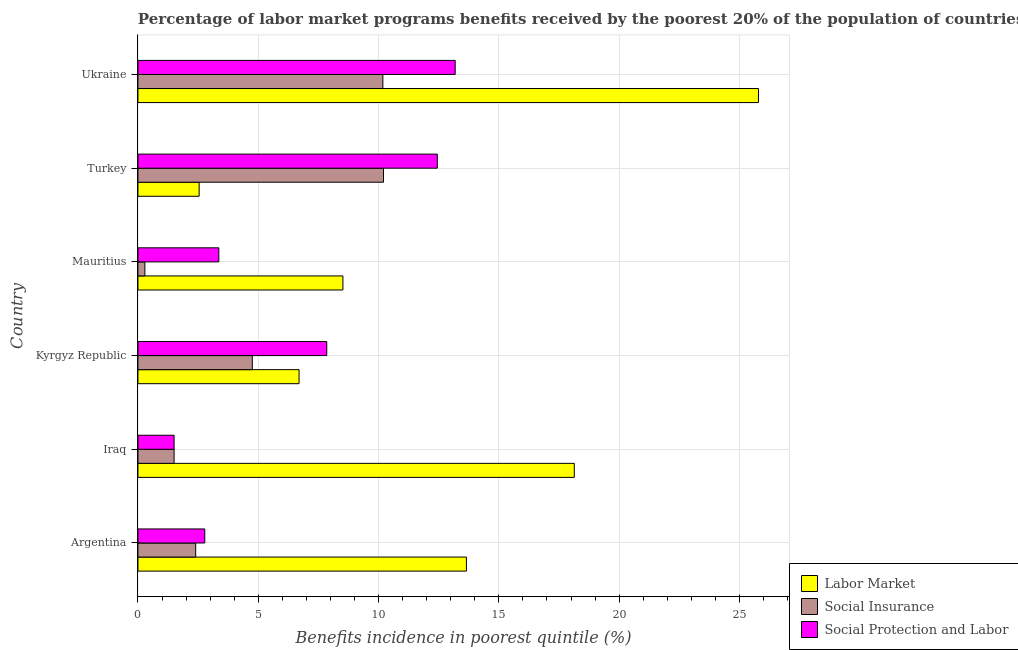How many different coloured bars are there?
Ensure brevity in your answer.  3. Are the number of bars per tick equal to the number of legend labels?
Your answer should be very brief. Yes. Are the number of bars on each tick of the Y-axis equal?
Offer a terse response. Yes. How many bars are there on the 4th tick from the top?
Your answer should be compact. 3. What is the label of the 1st group of bars from the top?
Your answer should be very brief. Ukraine. In how many cases, is the number of bars for a given country not equal to the number of legend labels?
Ensure brevity in your answer.  0. What is the percentage of benefits received due to social protection programs in Argentina?
Make the answer very short. 2.78. Across all countries, what is the maximum percentage of benefits received due to social insurance programs?
Your answer should be very brief. 10.21. Across all countries, what is the minimum percentage of benefits received due to social protection programs?
Keep it short and to the point. 1.5. In which country was the percentage of benefits received due to labor market programs minimum?
Your answer should be very brief. Turkey. What is the total percentage of benefits received due to social protection programs in the graph?
Give a very brief answer. 41.11. What is the difference between the percentage of benefits received due to social protection programs in Mauritius and that in Ukraine?
Offer a terse response. -9.82. What is the difference between the percentage of benefits received due to labor market programs in Turkey and the percentage of benefits received due to social insurance programs in Iraq?
Offer a very short reply. 1.04. What is the average percentage of benefits received due to social protection programs per country?
Keep it short and to the point. 6.85. What is the difference between the percentage of benefits received due to labor market programs and percentage of benefits received due to social protection programs in Kyrgyz Republic?
Ensure brevity in your answer.  -1.15. What is the ratio of the percentage of benefits received due to social insurance programs in Iraq to that in Ukraine?
Your answer should be very brief. 0.15. Is the percentage of benefits received due to social insurance programs in Iraq less than that in Turkey?
Give a very brief answer. Yes. What is the difference between the highest and the second highest percentage of benefits received due to social insurance programs?
Offer a terse response. 0.03. What is the difference between the highest and the lowest percentage of benefits received due to social protection programs?
Your answer should be very brief. 11.68. What does the 1st bar from the top in Mauritius represents?
Your response must be concise. Social Protection and Labor. What does the 2nd bar from the bottom in Argentina represents?
Make the answer very short. Social Insurance. How many bars are there?
Ensure brevity in your answer.  18. Are all the bars in the graph horizontal?
Provide a short and direct response. Yes. How many countries are there in the graph?
Your response must be concise. 6. What is the difference between two consecutive major ticks on the X-axis?
Ensure brevity in your answer.  5. Are the values on the major ticks of X-axis written in scientific E-notation?
Your answer should be compact. No. Does the graph contain any zero values?
Give a very brief answer. No. Does the graph contain grids?
Your response must be concise. Yes. Where does the legend appear in the graph?
Your response must be concise. Bottom right. How many legend labels are there?
Provide a succinct answer. 3. How are the legend labels stacked?
Provide a short and direct response. Vertical. What is the title of the graph?
Make the answer very short. Percentage of labor market programs benefits received by the poorest 20% of the population of countries. What is the label or title of the X-axis?
Offer a terse response. Benefits incidence in poorest quintile (%). What is the Benefits incidence in poorest quintile (%) of Labor Market in Argentina?
Your answer should be compact. 13.65. What is the Benefits incidence in poorest quintile (%) of Social Insurance in Argentina?
Give a very brief answer. 2.4. What is the Benefits incidence in poorest quintile (%) of Social Protection and Labor in Argentina?
Provide a succinct answer. 2.78. What is the Benefits incidence in poorest quintile (%) of Labor Market in Iraq?
Your answer should be compact. 18.14. What is the Benefits incidence in poorest quintile (%) in Social Insurance in Iraq?
Provide a short and direct response. 1.5. What is the Benefits incidence in poorest quintile (%) in Social Protection and Labor in Iraq?
Your answer should be compact. 1.5. What is the Benefits incidence in poorest quintile (%) of Labor Market in Kyrgyz Republic?
Make the answer very short. 6.7. What is the Benefits incidence in poorest quintile (%) of Social Insurance in Kyrgyz Republic?
Your answer should be compact. 4.75. What is the Benefits incidence in poorest quintile (%) of Social Protection and Labor in Kyrgyz Republic?
Provide a short and direct response. 7.85. What is the Benefits incidence in poorest quintile (%) of Labor Market in Mauritius?
Your answer should be very brief. 8.52. What is the Benefits incidence in poorest quintile (%) of Social Insurance in Mauritius?
Offer a very short reply. 0.29. What is the Benefits incidence in poorest quintile (%) in Social Protection and Labor in Mauritius?
Provide a succinct answer. 3.36. What is the Benefits incidence in poorest quintile (%) in Labor Market in Turkey?
Keep it short and to the point. 2.54. What is the Benefits incidence in poorest quintile (%) of Social Insurance in Turkey?
Give a very brief answer. 10.21. What is the Benefits incidence in poorest quintile (%) in Social Protection and Labor in Turkey?
Give a very brief answer. 12.44. What is the Benefits incidence in poorest quintile (%) of Labor Market in Ukraine?
Your answer should be compact. 25.79. What is the Benefits incidence in poorest quintile (%) of Social Insurance in Ukraine?
Make the answer very short. 10.18. What is the Benefits incidence in poorest quintile (%) in Social Protection and Labor in Ukraine?
Keep it short and to the point. 13.19. Across all countries, what is the maximum Benefits incidence in poorest quintile (%) of Labor Market?
Your answer should be very brief. 25.79. Across all countries, what is the maximum Benefits incidence in poorest quintile (%) in Social Insurance?
Ensure brevity in your answer.  10.21. Across all countries, what is the maximum Benefits incidence in poorest quintile (%) in Social Protection and Labor?
Provide a short and direct response. 13.19. Across all countries, what is the minimum Benefits incidence in poorest quintile (%) of Labor Market?
Your response must be concise. 2.54. Across all countries, what is the minimum Benefits incidence in poorest quintile (%) of Social Insurance?
Ensure brevity in your answer.  0.29. Across all countries, what is the minimum Benefits incidence in poorest quintile (%) of Social Protection and Labor?
Ensure brevity in your answer.  1.5. What is the total Benefits incidence in poorest quintile (%) in Labor Market in the graph?
Make the answer very short. 75.33. What is the total Benefits incidence in poorest quintile (%) of Social Insurance in the graph?
Provide a short and direct response. 29.33. What is the total Benefits incidence in poorest quintile (%) of Social Protection and Labor in the graph?
Give a very brief answer. 41.11. What is the difference between the Benefits incidence in poorest quintile (%) in Labor Market in Argentina and that in Iraq?
Your answer should be very brief. -4.48. What is the difference between the Benefits incidence in poorest quintile (%) in Social Insurance in Argentina and that in Iraq?
Your response must be concise. 0.9. What is the difference between the Benefits incidence in poorest quintile (%) in Social Protection and Labor in Argentina and that in Iraq?
Your response must be concise. 1.27. What is the difference between the Benefits incidence in poorest quintile (%) of Labor Market in Argentina and that in Kyrgyz Republic?
Provide a succinct answer. 6.96. What is the difference between the Benefits incidence in poorest quintile (%) in Social Insurance in Argentina and that in Kyrgyz Republic?
Offer a very short reply. -2.35. What is the difference between the Benefits incidence in poorest quintile (%) in Social Protection and Labor in Argentina and that in Kyrgyz Republic?
Your answer should be compact. -5.07. What is the difference between the Benefits incidence in poorest quintile (%) of Labor Market in Argentina and that in Mauritius?
Keep it short and to the point. 5.13. What is the difference between the Benefits incidence in poorest quintile (%) of Social Insurance in Argentina and that in Mauritius?
Provide a succinct answer. 2.11. What is the difference between the Benefits incidence in poorest quintile (%) in Social Protection and Labor in Argentina and that in Mauritius?
Provide a short and direct response. -0.58. What is the difference between the Benefits incidence in poorest quintile (%) of Labor Market in Argentina and that in Turkey?
Ensure brevity in your answer.  11.11. What is the difference between the Benefits incidence in poorest quintile (%) of Social Insurance in Argentina and that in Turkey?
Provide a succinct answer. -7.81. What is the difference between the Benefits incidence in poorest quintile (%) of Social Protection and Labor in Argentina and that in Turkey?
Give a very brief answer. -9.66. What is the difference between the Benefits incidence in poorest quintile (%) of Labor Market in Argentina and that in Ukraine?
Provide a succinct answer. -12.14. What is the difference between the Benefits incidence in poorest quintile (%) in Social Insurance in Argentina and that in Ukraine?
Offer a very short reply. -7.78. What is the difference between the Benefits incidence in poorest quintile (%) of Social Protection and Labor in Argentina and that in Ukraine?
Your answer should be very brief. -10.41. What is the difference between the Benefits incidence in poorest quintile (%) of Labor Market in Iraq and that in Kyrgyz Republic?
Offer a very short reply. 11.44. What is the difference between the Benefits incidence in poorest quintile (%) of Social Insurance in Iraq and that in Kyrgyz Republic?
Your response must be concise. -3.25. What is the difference between the Benefits incidence in poorest quintile (%) in Social Protection and Labor in Iraq and that in Kyrgyz Republic?
Make the answer very short. -6.34. What is the difference between the Benefits incidence in poorest quintile (%) in Labor Market in Iraq and that in Mauritius?
Your response must be concise. 9.62. What is the difference between the Benefits incidence in poorest quintile (%) of Social Insurance in Iraq and that in Mauritius?
Make the answer very short. 1.22. What is the difference between the Benefits incidence in poorest quintile (%) of Social Protection and Labor in Iraq and that in Mauritius?
Ensure brevity in your answer.  -1.86. What is the difference between the Benefits incidence in poorest quintile (%) of Labor Market in Iraq and that in Turkey?
Make the answer very short. 15.59. What is the difference between the Benefits incidence in poorest quintile (%) of Social Insurance in Iraq and that in Turkey?
Your answer should be very brief. -8.7. What is the difference between the Benefits incidence in poorest quintile (%) of Social Protection and Labor in Iraq and that in Turkey?
Make the answer very short. -10.94. What is the difference between the Benefits incidence in poorest quintile (%) in Labor Market in Iraq and that in Ukraine?
Provide a short and direct response. -7.65. What is the difference between the Benefits incidence in poorest quintile (%) in Social Insurance in Iraq and that in Ukraine?
Ensure brevity in your answer.  -8.68. What is the difference between the Benefits incidence in poorest quintile (%) of Social Protection and Labor in Iraq and that in Ukraine?
Ensure brevity in your answer.  -11.68. What is the difference between the Benefits incidence in poorest quintile (%) in Labor Market in Kyrgyz Republic and that in Mauritius?
Offer a terse response. -1.82. What is the difference between the Benefits incidence in poorest quintile (%) in Social Insurance in Kyrgyz Republic and that in Mauritius?
Offer a very short reply. 4.47. What is the difference between the Benefits incidence in poorest quintile (%) of Social Protection and Labor in Kyrgyz Republic and that in Mauritius?
Provide a succinct answer. 4.49. What is the difference between the Benefits incidence in poorest quintile (%) of Labor Market in Kyrgyz Republic and that in Turkey?
Give a very brief answer. 4.15. What is the difference between the Benefits incidence in poorest quintile (%) in Social Insurance in Kyrgyz Republic and that in Turkey?
Give a very brief answer. -5.45. What is the difference between the Benefits incidence in poorest quintile (%) of Social Protection and Labor in Kyrgyz Republic and that in Turkey?
Your response must be concise. -4.59. What is the difference between the Benefits incidence in poorest quintile (%) in Labor Market in Kyrgyz Republic and that in Ukraine?
Your answer should be very brief. -19.09. What is the difference between the Benefits incidence in poorest quintile (%) in Social Insurance in Kyrgyz Republic and that in Ukraine?
Offer a very short reply. -5.43. What is the difference between the Benefits incidence in poorest quintile (%) of Social Protection and Labor in Kyrgyz Republic and that in Ukraine?
Offer a terse response. -5.34. What is the difference between the Benefits incidence in poorest quintile (%) in Labor Market in Mauritius and that in Turkey?
Offer a terse response. 5.97. What is the difference between the Benefits incidence in poorest quintile (%) in Social Insurance in Mauritius and that in Turkey?
Make the answer very short. -9.92. What is the difference between the Benefits incidence in poorest quintile (%) of Social Protection and Labor in Mauritius and that in Turkey?
Make the answer very short. -9.08. What is the difference between the Benefits incidence in poorest quintile (%) in Labor Market in Mauritius and that in Ukraine?
Provide a succinct answer. -17.27. What is the difference between the Benefits incidence in poorest quintile (%) in Social Insurance in Mauritius and that in Ukraine?
Give a very brief answer. -9.89. What is the difference between the Benefits incidence in poorest quintile (%) in Social Protection and Labor in Mauritius and that in Ukraine?
Give a very brief answer. -9.82. What is the difference between the Benefits incidence in poorest quintile (%) in Labor Market in Turkey and that in Ukraine?
Provide a succinct answer. -23.25. What is the difference between the Benefits incidence in poorest quintile (%) in Social Insurance in Turkey and that in Ukraine?
Provide a short and direct response. 0.03. What is the difference between the Benefits incidence in poorest quintile (%) of Social Protection and Labor in Turkey and that in Ukraine?
Your response must be concise. -0.74. What is the difference between the Benefits incidence in poorest quintile (%) of Labor Market in Argentina and the Benefits incidence in poorest quintile (%) of Social Insurance in Iraq?
Offer a very short reply. 12.15. What is the difference between the Benefits incidence in poorest quintile (%) in Labor Market in Argentina and the Benefits incidence in poorest quintile (%) in Social Protection and Labor in Iraq?
Make the answer very short. 12.15. What is the difference between the Benefits incidence in poorest quintile (%) in Social Insurance in Argentina and the Benefits incidence in poorest quintile (%) in Social Protection and Labor in Iraq?
Your answer should be compact. 0.9. What is the difference between the Benefits incidence in poorest quintile (%) in Labor Market in Argentina and the Benefits incidence in poorest quintile (%) in Social Insurance in Kyrgyz Republic?
Offer a very short reply. 8.9. What is the difference between the Benefits incidence in poorest quintile (%) in Labor Market in Argentina and the Benefits incidence in poorest quintile (%) in Social Protection and Labor in Kyrgyz Republic?
Your answer should be very brief. 5.8. What is the difference between the Benefits incidence in poorest quintile (%) of Social Insurance in Argentina and the Benefits incidence in poorest quintile (%) of Social Protection and Labor in Kyrgyz Republic?
Your response must be concise. -5.45. What is the difference between the Benefits incidence in poorest quintile (%) in Labor Market in Argentina and the Benefits incidence in poorest quintile (%) in Social Insurance in Mauritius?
Ensure brevity in your answer.  13.36. What is the difference between the Benefits incidence in poorest quintile (%) in Labor Market in Argentina and the Benefits incidence in poorest quintile (%) in Social Protection and Labor in Mauritius?
Make the answer very short. 10.29. What is the difference between the Benefits incidence in poorest quintile (%) in Social Insurance in Argentina and the Benefits incidence in poorest quintile (%) in Social Protection and Labor in Mauritius?
Keep it short and to the point. -0.96. What is the difference between the Benefits incidence in poorest quintile (%) in Labor Market in Argentina and the Benefits incidence in poorest quintile (%) in Social Insurance in Turkey?
Your response must be concise. 3.45. What is the difference between the Benefits incidence in poorest quintile (%) of Labor Market in Argentina and the Benefits incidence in poorest quintile (%) of Social Protection and Labor in Turkey?
Your response must be concise. 1.21. What is the difference between the Benefits incidence in poorest quintile (%) in Social Insurance in Argentina and the Benefits incidence in poorest quintile (%) in Social Protection and Labor in Turkey?
Provide a succinct answer. -10.04. What is the difference between the Benefits incidence in poorest quintile (%) in Labor Market in Argentina and the Benefits incidence in poorest quintile (%) in Social Insurance in Ukraine?
Provide a short and direct response. 3.47. What is the difference between the Benefits incidence in poorest quintile (%) of Labor Market in Argentina and the Benefits incidence in poorest quintile (%) of Social Protection and Labor in Ukraine?
Offer a terse response. 0.47. What is the difference between the Benefits incidence in poorest quintile (%) of Social Insurance in Argentina and the Benefits incidence in poorest quintile (%) of Social Protection and Labor in Ukraine?
Keep it short and to the point. -10.79. What is the difference between the Benefits incidence in poorest quintile (%) of Labor Market in Iraq and the Benefits incidence in poorest quintile (%) of Social Insurance in Kyrgyz Republic?
Offer a very short reply. 13.38. What is the difference between the Benefits incidence in poorest quintile (%) in Labor Market in Iraq and the Benefits incidence in poorest quintile (%) in Social Protection and Labor in Kyrgyz Republic?
Make the answer very short. 10.29. What is the difference between the Benefits incidence in poorest quintile (%) in Social Insurance in Iraq and the Benefits incidence in poorest quintile (%) in Social Protection and Labor in Kyrgyz Republic?
Make the answer very short. -6.34. What is the difference between the Benefits incidence in poorest quintile (%) in Labor Market in Iraq and the Benefits incidence in poorest quintile (%) in Social Insurance in Mauritius?
Your response must be concise. 17.85. What is the difference between the Benefits incidence in poorest quintile (%) in Labor Market in Iraq and the Benefits incidence in poorest quintile (%) in Social Protection and Labor in Mauritius?
Your answer should be very brief. 14.78. What is the difference between the Benefits incidence in poorest quintile (%) of Social Insurance in Iraq and the Benefits incidence in poorest quintile (%) of Social Protection and Labor in Mauritius?
Ensure brevity in your answer.  -1.86. What is the difference between the Benefits incidence in poorest quintile (%) in Labor Market in Iraq and the Benefits incidence in poorest quintile (%) in Social Insurance in Turkey?
Give a very brief answer. 7.93. What is the difference between the Benefits incidence in poorest quintile (%) in Labor Market in Iraq and the Benefits incidence in poorest quintile (%) in Social Protection and Labor in Turkey?
Your answer should be compact. 5.69. What is the difference between the Benefits incidence in poorest quintile (%) in Social Insurance in Iraq and the Benefits incidence in poorest quintile (%) in Social Protection and Labor in Turkey?
Provide a succinct answer. -10.94. What is the difference between the Benefits incidence in poorest quintile (%) in Labor Market in Iraq and the Benefits incidence in poorest quintile (%) in Social Insurance in Ukraine?
Your answer should be very brief. 7.96. What is the difference between the Benefits incidence in poorest quintile (%) in Labor Market in Iraq and the Benefits incidence in poorest quintile (%) in Social Protection and Labor in Ukraine?
Provide a succinct answer. 4.95. What is the difference between the Benefits incidence in poorest quintile (%) in Social Insurance in Iraq and the Benefits incidence in poorest quintile (%) in Social Protection and Labor in Ukraine?
Offer a very short reply. -11.68. What is the difference between the Benefits incidence in poorest quintile (%) in Labor Market in Kyrgyz Republic and the Benefits incidence in poorest quintile (%) in Social Insurance in Mauritius?
Your response must be concise. 6.41. What is the difference between the Benefits incidence in poorest quintile (%) of Labor Market in Kyrgyz Republic and the Benefits incidence in poorest quintile (%) of Social Protection and Labor in Mauritius?
Keep it short and to the point. 3.34. What is the difference between the Benefits incidence in poorest quintile (%) of Social Insurance in Kyrgyz Republic and the Benefits incidence in poorest quintile (%) of Social Protection and Labor in Mauritius?
Your answer should be very brief. 1.39. What is the difference between the Benefits incidence in poorest quintile (%) in Labor Market in Kyrgyz Republic and the Benefits incidence in poorest quintile (%) in Social Insurance in Turkey?
Offer a very short reply. -3.51. What is the difference between the Benefits incidence in poorest quintile (%) of Labor Market in Kyrgyz Republic and the Benefits incidence in poorest quintile (%) of Social Protection and Labor in Turkey?
Make the answer very short. -5.75. What is the difference between the Benefits incidence in poorest quintile (%) of Social Insurance in Kyrgyz Republic and the Benefits incidence in poorest quintile (%) of Social Protection and Labor in Turkey?
Give a very brief answer. -7.69. What is the difference between the Benefits incidence in poorest quintile (%) in Labor Market in Kyrgyz Republic and the Benefits incidence in poorest quintile (%) in Social Insurance in Ukraine?
Keep it short and to the point. -3.48. What is the difference between the Benefits incidence in poorest quintile (%) in Labor Market in Kyrgyz Republic and the Benefits incidence in poorest quintile (%) in Social Protection and Labor in Ukraine?
Provide a short and direct response. -6.49. What is the difference between the Benefits incidence in poorest quintile (%) in Social Insurance in Kyrgyz Republic and the Benefits incidence in poorest quintile (%) in Social Protection and Labor in Ukraine?
Offer a terse response. -8.43. What is the difference between the Benefits incidence in poorest quintile (%) of Labor Market in Mauritius and the Benefits incidence in poorest quintile (%) of Social Insurance in Turkey?
Offer a terse response. -1.69. What is the difference between the Benefits incidence in poorest quintile (%) of Labor Market in Mauritius and the Benefits incidence in poorest quintile (%) of Social Protection and Labor in Turkey?
Provide a succinct answer. -3.92. What is the difference between the Benefits incidence in poorest quintile (%) of Social Insurance in Mauritius and the Benefits incidence in poorest quintile (%) of Social Protection and Labor in Turkey?
Provide a short and direct response. -12.15. What is the difference between the Benefits incidence in poorest quintile (%) in Labor Market in Mauritius and the Benefits incidence in poorest quintile (%) in Social Insurance in Ukraine?
Make the answer very short. -1.66. What is the difference between the Benefits incidence in poorest quintile (%) of Labor Market in Mauritius and the Benefits incidence in poorest quintile (%) of Social Protection and Labor in Ukraine?
Provide a short and direct response. -4.67. What is the difference between the Benefits incidence in poorest quintile (%) in Social Insurance in Mauritius and the Benefits incidence in poorest quintile (%) in Social Protection and Labor in Ukraine?
Provide a short and direct response. -12.9. What is the difference between the Benefits incidence in poorest quintile (%) in Labor Market in Turkey and the Benefits incidence in poorest quintile (%) in Social Insurance in Ukraine?
Your answer should be very brief. -7.64. What is the difference between the Benefits incidence in poorest quintile (%) of Labor Market in Turkey and the Benefits incidence in poorest quintile (%) of Social Protection and Labor in Ukraine?
Your answer should be compact. -10.64. What is the difference between the Benefits incidence in poorest quintile (%) of Social Insurance in Turkey and the Benefits incidence in poorest quintile (%) of Social Protection and Labor in Ukraine?
Make the answer very short. -2.98. What is the average Benefits incidence in poorest quintile (%) of Labor Market per country?
Your answer should be very brief. 12.56. What is the average Benefits incidence in poorest quintile (%) of Social Insurance per country?
Your response must be concise. 4.89. What is the average Benefits incidence in poorest quintile (%) in Social Protection and Labor per country?
Keep it short and to the point. 6.85. What is the difference between the Benefits incidence in poorest quintile (%) of Labor Market and Benefits incidence in poorest quintile (%) of Social Insurance in Argentina?
Ensure brevity in your answer.  11.25. What is the difference between the Benefits incidence in poorest quintile (%) in Labor Market and Benefits incidence in poorest quintile (%) in Social Protection and Labor in Argentina?
Give a very brief answer. 10.88. What is the difference between the Benefits incidence in poorest quintile (%) in Social Insurance and Benefits incidence in poorest quintile (%) in Social Protection and Labor in Argentina?
Provide a succinct answer. -0.38. What is the difference between the Benefits incidence in poorest quintile (%) in Labor Market and Benefits incidence in poorest quintile (%) in Social Insurance in Iraq?
Your answer should be very brief. 16.63. What is the difference between the Benefits incidence in poorest quintile (%) of Labor Market and Benefits incidence in poorest quintile (%) of Social Protection and Labor in Iraq?
Provide a succinct answer. 16.63. What is the difference between the Benefits incidence in poorest quintile (%) in Labor Market and Benefits incidence in poorest quintile (%) in Social Insurance in Kyrgyz Republic?
Your answer should be compact. 1.94. What is the difference between the Benefits incidence in poorest quintile (%) in Labor Market and Benefits incidence in poorest quintile (%) in Social Protection and Labor in Kyrgyz Republic?
Your response must be concise. -1.15. What is the difference between the Benefits incidence in poorest quintile (%) of Social Insurance and Benefits incidence in poorest quintile (%) of Social Protection and Labor in Kyrgyz Republic?
Provide a succinct answer. -3.09. What is the difference between the Benefits incidence in poorest quintile (%) in Labor Market and Benefits incidence in poorest quintile (%) in Social Insurance in Mauritius?
Ensure brevity in your answer.  8.23. What is the difference between the Benefits incidence in poorest quintile (%) of Labor Market and Benefits incidence in poorest quintile (%) of Social Protection and Labor in Mauritius?
Your answer should be very brief. 5.16. What is the difference between the Benefits incidence in poorest quintile (%) of Social Insurance and Benefits incidence in poorest quintile (%) of Social Protection and Labor in Mauritius?
Offer a very short reply. -3.07. What is the difference between the Benefits incidence in poorest quintile (%) of Labor Market and Benefits incidence in poorest quintile (%) of Social Insurance in Turkey?
Your answer should be compact. -7.66. What is the difference between the Benefits incidence in poorest quintile (%) in Labor Market and Benefits incidence in poorest quintile (%) in Social Protection and Labor in Turkey?
Provide a succinct answer. -9.9. What is the difference between the Benefits incidence in poorest quintile (%) in Social Insurance and Benefits incidence in poorest quintile (%) in Social Protection and Labor in Turkey?
Keep it short and to the point. -2.24. What is the difference between the Benefits incidence in poorest quintile (%) in Labor Market and Benefits incidence in poorest quintile (%) in Social Insurance in Ukraine?
Ensure brevity in your answer.  15.61. What is the difference between the Benefits incidence in poorest quintile (%) in Labor Market and Benefits incidence in poorest quintile (%) in Social Protection and Labor in Ukraine?
Offer a terse response. 12.61. What is the difference between the Benefits incidence in poorest quintile (%) in Social Insurance and Benefits incidence in poorest quintile (%) in Social Protection and Labor in Ukraine?
Give a very brief answer. -3.01. What is the ratio of the Benefits incidence in poorest quintile (%) of Labor Market in Argentina to that in Iraq?
Provide a short and direct response. 0.75. What is the ratio of the Benefits incidence in poorest quintile (%) of Social Insurance in Argentina to that in Iraq?
Offer a very short reply. 1.6. What is the ratio of the Benefits incidence in poorest quintile (%) of Social Protection and Labor in Argentina to that in Iraq?
Your answer should be compact. 1.85. What is the ratio of the Benefits incidence in poorest quintile (%) in Labor Market in Argentina to that in Kyrgyz Republic?
Provide a short and direct response. 2.04. What is the ratio of the Benefits incidence in poorest quintile (%) in Social Insurance in Argentina to that in Kyrgyz Republic?
Your answer should be compact. 0.5. What is the ratio of the Benefits incidence in poorest quintile (%) in Social Protection and Labor in Argentina to that in Kyrgyz Republic?
Provide a succinct answer. 0.35. What is the ratio of the Benefits incidence in poorest quintile (%) of Labor Market in Argentina to that in Mauritius?
Ensure brevity in your answer.  1.6. What is the ratio of the Benefits incidence in poorest quintile (%) in Social Insurance in Argentina to that in Mauritius?
Provide a short and direct response. 8.34. What is the ratio of the Benefits incidence in poorest quintile (%) of Social Protection and Labor in Argentina to that in Mauritius?
Offer a terse response. 0.83. What is the ratio of the Benefits incidence in poorest quintile (%) of Labor Market in Argentina to that in Turkey?
Your answer should be compact. 5.37. What is the ratio of the Benefits incidence in poorest quintile (%) of Social Insurance in Argentina to that in Turkey?
Your answer should be compact. 0.23. What is the ratio of the Benefits incidence in poorest quintile (%) of Social Protection and Labor in Argentina to that in Turkey?
Keep it short and to the point. 0.22. What is the ratio of the Benefits incidence in poorest quintile (%) of Labor Market in Argentina to that in Ukraine?
Keep it short and to the point. 0.53. What is the ratio of the Benefits incidence in poorest quintile (%) of Social Insurance in Argentina to that in Ukraine?
Offer a very short reply. 0.24. What is the ratio of the Benefits incidence in poorest quintile (%) in Social Protection and Labor in Argentina to that in Ukraine?
Ensure brevity in your answer.  0.21. What is the ratio of the Benefits incidence in poorest quintile (%) of Labor Market in Iraq to that in Kyrgyz Republic?
Offer a very short reply. 2.71. What is the ratio of the Benefits incidence in poorest quintile (%) in Social Insurance in Iraq to that in Kyrgyz Republic?
Your response must be concise. 0.32. What is the ratio of the Benefits incidence in poorest quintile (%) of Social Protection and Labor in Iraq to that in Kyrgyz Republic?
Give a very brief answer. 0.19. What is the ratio of the Benefits incidence in poorest quintile (%) in Labor Market in Iraq to that in Mauritius?
Give a very brief answer. 2.13. What is the ratio of the Benefits incidence in poorest quintile (%) of Social Insurance in Iraq to that in Mauritius?
Your answer should be very brief. 5.23. What is the ratio of the Benefits incidence in poorest quintile (%) of Social Protection and Labor in Iraq to that in Mauritius?
Your answer should be very brief. 0.45. What is the ratio of the Benefits incidence in poorest quintile (%) in Labor Market in Iraq to that in Turkey?
Ensure brevity in your answer.  7.13. What is the ratio of the Benefits incidence in poorest quintile (%) in Social Insurance in Iraq to that in Turkey?
Give a very brief answer. 0.15. What is the ratio of the Benefits incidence in poorest quintile (%) of Social Protection and Labor in Iraq to that in Turkey?
Your answer should be very brief. 0.12. What is the ratio of the Benefits incidence in poorest quintile (%) of Labor Market in Iraq to that in Ukraine?
Give a very brief answer. 0.7. What is the ratio of the Benefits incidence in poorest quintile (%) in Social Insurance in Iraq to that in Ukraine?
Offer a terse response. 0.15. What is the ratio of the Benefits incidence in poorest quintile (%) of Social Protection and Labor in Iraq to that in Ukraine?
Provide a succinct answer. 0.11. What is the ratio of the Benefits incidence in poorest quintile (%) of Labor Market in Kyrgyz Republic to that in Mauritius?
Ensure brevity in your answer.  0.79. What is the ratio of the Benefits incidence in poorest quintile (%) of Social Insurance in Kyrgyz Republic to that in Mauritius?
Give a very brief answer. 16.53. What is the ratio of the Benefits incidence in poorest quintile (%) of Social Protection and Labor in Kyrgyz Republic to that in Mauritius?
Give a very brief answer. 2.34. What is the ratio of the Benefits incidence in poorest quintile (%) in Labor Market in Kyrgyz Republic to that in Turkey?
Keep it short and to the point. 2.63. What is the ratio of the Benefits incidence in poorest quintile (%) in Social Insurance in Kyrgyz Republic to that in Turkey?
Offer a very short reply. 0.47. What is the ratio of the Benefits incidence in poorest quintile (%) in Social Protection and Labor in Kyrgyz Republic to that in Turkey?
Offer a very short reply. 0.63. What is the ratio of the Benefits incidence in poorest quintile (%) of Labor Market in Kyrgyz Republic to that in Ukraine?
Your answer should be very brief. 0.26. What is the ratio of the Benefits incidence in poorest quintile (%) in Social Insurance in Kyrgyz Republic to that in Ukraine?
Make the answer very short. 0.47. What is the ratio of the Benefits incidence in poorest quintile (%) of Social Protection and Labor in Kyrgyz Republic to that in Ukraine?
Provide a short and direct response. 0.6. What is the ratio of the Benefits incidence in poorest quintile (%) of Labor Market in Mauritius to that in Turkey?
Keep it short and to the point. 3.35. What is the ratio of the Benefits incidence in poorest quintile (%) of Social Insurance in Mauritius to that in Turkey?
Give a very brief answer. 0.03. What is the ratio of the Benefits incidence in poorest quintile (%) of Social Protection and Labor in Mauritius to that in Turkey?
Make the answer very short. 0.27. What is the ratio of the Benefits incidence in poorest quintile (%) of Labor Market in Mauritius to that in Ukraine?
Offer a very short reply. 0.33. What is the ratio of the Benefits incidence in poorest quintile (%) of Social Insurance in Mauritius to that in Ukraine?
Give a very brief answer. 0.03. What is the ratio of the Benefits incidence in poorest quintile (%) in Social Protection and Labor in Mauritius to that in Ukraine?
Give a very brief answer. 0.25. What is the ratio of the Benefits incidence in poorest quintile (%) in Labor Market in Turkey to that in Ukraine?
Your response must be concise. 0.1. What is the ratio of the Benefits incidence in poorest quintile (%) in Social Insurance in Turkey to that in Ukraine?
Give a very brief answer. 1. What is the ratio of the Benefits incidence in poorest quintile (%) in Social Protection and Labor in Turkey to that in Ukraine?
Keep it short and to the point. 0.94. What is the difference between the highest and the second highest Benefits incidence in poorest quintile (%) in Labor Market?
Offer a very short reply. 7.65. What is the difference between the highest and the second highest Benefits incidence in poorest quintile (%) in Social Insurance?
Provide a succinct answer. 0.03. What is the difference between the highest and the second highest Benefits incidence in poorest quintile (%) in Social Protection and Labor?
Provide a succinct answer. 0.74. What is the difference between the highest and the lowest Benefits incidence in poorest quintile (%) in Labor Market?
Give a very brief answer. 23.25. What is the difference between the highest and the lowest Benefits incidence in poorest quintile (%) in Social Insurance?
Your answer should be compact. 9.92. What is the difference between the highest and the lowest Benefits incidence in poorest quintile (%) of Social Protection and Labor?
Provide a short and direct response. 11.68. 